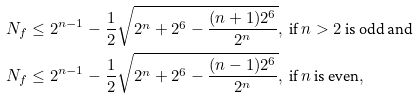Convert formula to latex. <formula><loc_0><loc_0><loc_500><loc_500>& N _ { f } \leq 2 ^ { n - 1 } - \frac { 1 } { 2 } \sqrt { 2 ^ { n } + 2 ^ { 6 } - \frac { ( n + 1 ) 2 ^ { 6 } } { 2 ^ { n } } } , \ \text {if $n>2$ is odd and} \\ & N _ { f } \leq 2 ^ { n - 1 } - \frac { 1 } { 2 } \sqrt { 2 ^ { n } + 2 ^ { 6 } - \frac { ( n - 1 ) 2 ^ { 6 } } { 2 ^ { n } } } , \ \text {if $n$ is even} ,</formula> 